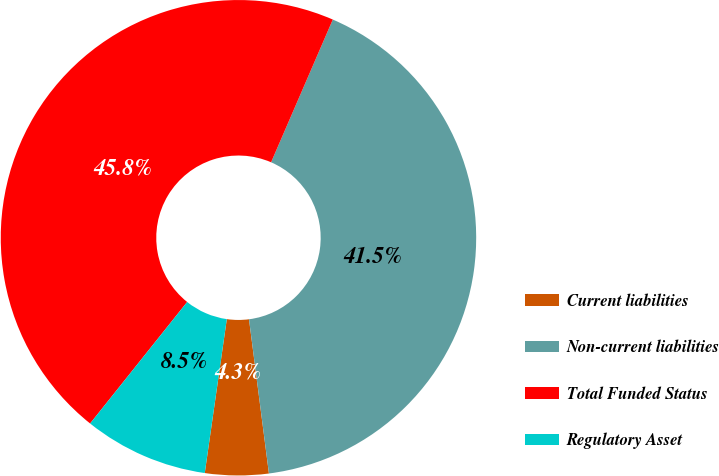Convert chart to OTSL. <chart><loc_0><loc_0><loc_500><loc_500><pie_chart><fcel>Current liabilities<fcel>Non-current liabilities<fcel>Total Funded Status<fcel>Regulatory Asset<nl><fcel>4.31%<fcel>41.46%<fcel>45.77%<fcel>8.46%<nl></chart> 